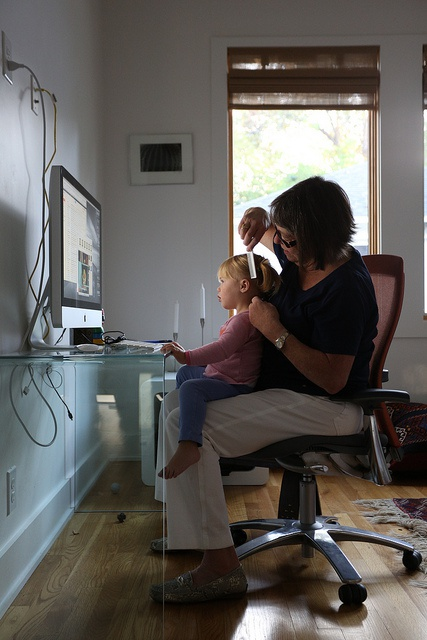Describe the objects in this image and their specific colors. I can see people in gray and black tones, chair in gray, black, maroon, and darkgray tones, people in gray, black, and maroon tones, tv in gray, lightgray, darkgray, and black tones, and keyboard in gray, darkgray, black, and lightgray tones in this image. 